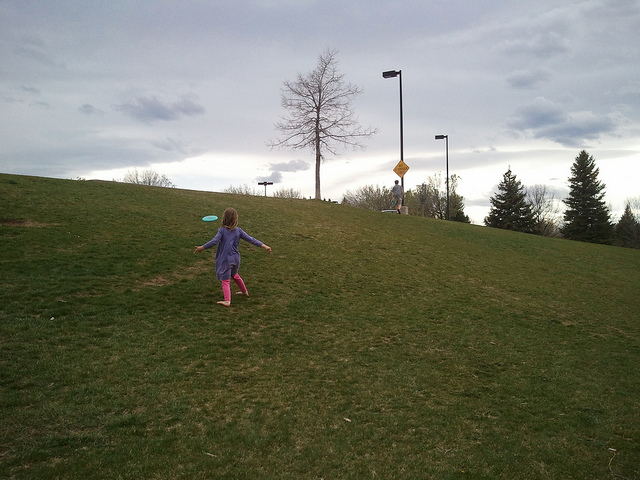<image>What type of shoes is she wearing? She is not wearing any shoes. However, it's ambiguous without a visual context. What type of shoes is she wearing? It is unclear what type of shoes she is wearing. It can be seen as regular, flat or no shoes. 